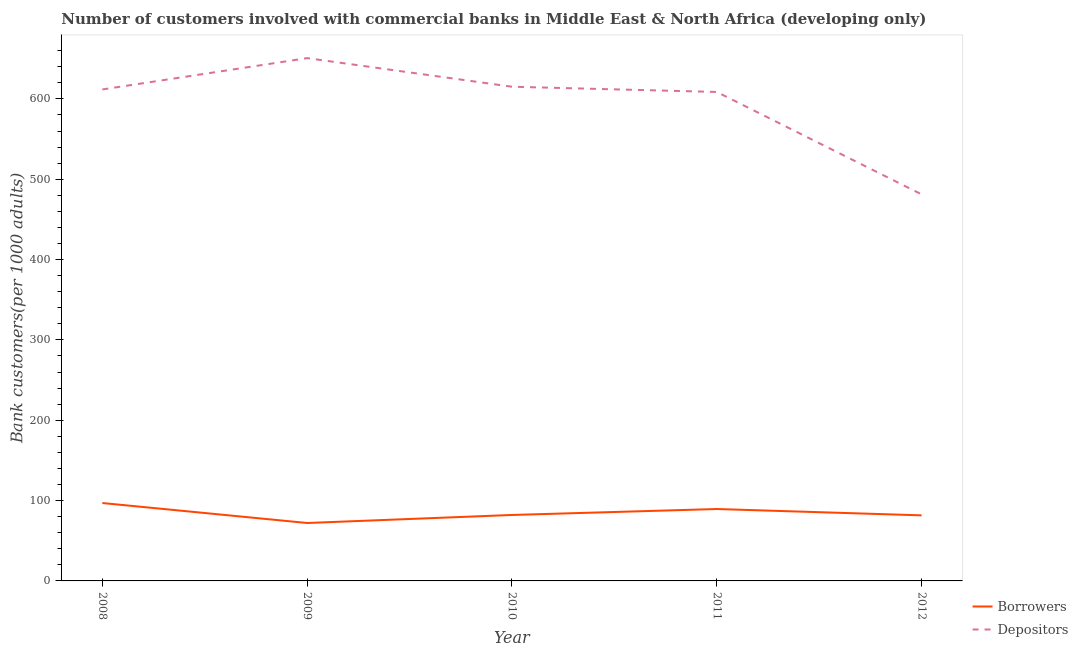How many different coloured lines are there?
Offer a very short reply. 2. Is the number of lines equal to the number of legend labels?
Your answer should be compact. Yes. What is the number of depositors in 2009?
Your answer should be very brief. 650.77. Across all years, what is the maximum number of borrowers?
Give a very brief answer. 96.96. Across all years, what is the minimum number of borrowers?
Offer a terse response. 72.11. What is the total number of depositors in the graph?
Your answer should be very brief. 2967.5. What is the difference between the number of borrowers in 2011 and that in 2012?
Your answer should be compact. 7.9. What is the difference between the number of depositors in 2009 and the number of borrowers in 2010?
Offer a very short reply. 568.67. What is the average number of borrowers per year?
Provide a succinct answer. 84.46. In the year 2010, what is the difference between the number of borrowers and number of depositors?
Provide a succinct answer. -533.06. What is the ratio of the number of depositors in 2009 to that in 2011?
Your answer should be very brief. 1.07. Is the difference between the number of borrowers in 2010 and 2012 greater than the difference between the number of depositors in 2010 and 2012?
Give a very brief answer. No. What is the difference between the highest and the second highest number of depositors?
Give a very brief answer. 35.61. What is the difference between the highest and the lowest number of borrowers?
Offer a very short reply. 24.86. Does the number of borrowers monotonically increase over the years?
Give a very brief answer. No. Is the number of depositors strictly greater than the number of borrowers over the years?
Provide a succinct answer. Yes. Is the number of depositors strictly less than the number of borrowers over the years?
Your answer should be compact. No. How many lines are there?
Keep it short and to the point. 2. How many years are there in the graph?
Offer a very short reply. 5. Does the graph contain any zero values?
Provide a short and direct response. No. Does the graph contain grids?
Make the answer very short. No. Where does the legend appear in the graph?
Your answer should be very brief. Bottom right. How many legend labels are there?
Your answer should be very brief. 2. How are the legend labels stacked?
Your answer should be compact. Vertical. What is the title of the graph?
Ensure brevity in your answer.  Number of customers involved with commercial banks in Middle East & North Africa (developing only). What is the label or title of the X-axis?
Ensure brevity in your answer.  Year. What is the label or title of the Y-axis?
Your response must be concise. Bank customers(per 1000 adults). What is the Bank customers(per 1000 adults) in Borrowers in 2008?
Your response must be concise. 96.96. What is the Bank customers(per 1000 adults) in Depositors in 2008?
Provide a short and direct response. 611.77. What is the Bank customers(per 1000 adults) in Borrowers in 2009?
Give a very brief answer. 72.11. What is the Bank customers(per 1000 adults) of Depositors in 2009?
Provide a succinct answer. 650.77. What is the Bank customers(per 1000 adults) in Borrowers in 2010?
Your answer should be very brief. 82.1. What is the Bank customers(per 1000 adults) in Depositors in 2010?
Provide a short and direct response. 615.16. What is the Bank customers(per 1000 adults) in Borrowers in 2011?
Your response must be concise. 89.5. What is the Bank customers(per 1000 adults) in Depositors in 2011?
Make the answer very short. 608.64. What is the Bank customers(per 1000 adults) of Borrowers in 2012?
Offer a terse response. 81.61. What is the Bank customers(per 1000 adults) in Depositors in 2012?
Provide a short and direct response. 481.17. Across all years, what is the maximum Bank customers(per 1000 adults) in Borrowers?
Offer a very short reply. 96.96. Across all years, what is the maximum Bank customers(per 1000 adults) of Depositors?
Provide a short and direct response. 650.77. Across all years, what is the minimum Bank customers(per 1000 adults) in Borrowers?
Provide a succinct answer. 72.11. Across all years, what is the minimum Bank customers(per 1000 adults) in Depositors?
Give a very brief answer. 481.17. What is the total Bank customers(per 1000 adults) of Borrowers in the graph?
Offer a very short reply. 422.28. What is the total Bank customers(per 1000 adults) of Depositors in the graph?
Your response must be concise. 2967.5. What is the difference between the Bank customers(per 1000 adults) of Borrowers in 2008 and that in 2009?
Your answer should be compact. 24.86. What is the difference between the Bank customers(per 1000 adults) of Depositors in 2008 and that in 2009?
Provide a succinct answer. -39. What is the difference between the Bank customers(per 1000 adults) of Borrowers in 2008 and that in 2010?
Ensure brevity in your answer.  14.86. What is the difference between the Bank customers(per 1000 adults) in Depositors in 2008 and that in 2010?
Your response must be concise. -3.39. What is the difference between the Bank customers(per 1000 adults) in Borrowers in 2008 and that in 2011?
Your answer should be very brief. 7.46. What is the difference between the Bank customers(per 1000 adults) in Depositors in 2008 and that in 2011?
Your answer should be compact. 3.13. What is the difference between the Bank customers(per 1000 adults) in Borrowers in 2008 and that in 2012?
Your response must be concise. 15.36. What is the difference between the Bank customers(per 1000 adults) of Depositors in 2008 and that in 2012?
Offer a terse response. 130.6. What is the difference between the Bank customers(per 1000 adults) of Borrowers in 2009 and that in 2010?
Your response must be concise. -10. What is the difference between the Bank customers(per 1000 adults) of Depositors in 2009 and that in 2010?
Your answer should be very brief. 35.61. What is the difference between the Bank customers(per 1000 adults) in Borrowers in 2009 and that in 2011?
Offer a very short reply. -17.4. What is the difference between the Bank customers(per 1000 adults) of Depositors in 2009 and that in 2011?
Your response must be concise. 42.13. What is the difference between the Bank customers(per 1000 adults) in Borrowers in 2009 and that in 2012?
Provide a succinct answer. -9.5. What is the difference between the Bank customers(per 1000 adults) in Depositors in 2009 and that in 2012?
Give a very brief answer. 169.6. What is the difference between the Bank customers(per 1000 adults) of Borrowers in 2010 and that in 2011?
Offer a very short reply. -7.4. What is the difference between the Bank customers(per 1000 adults) in Depositors in 2010 and that in 2011?
Provide a succinct answer. 6.52. What is the difference between the Bank customers(per 1000 adults) of Borrowers in 2010 and that in 2012?
Make the answer very short. 0.5. What is the difference between the Bank customers(per 1000 adults) in Depositors in 2010 and that in 2012?
Give a very brief answer. 133.99. What is the difference between the Bank customers(per 1000 adults) of Borrowers in 2011 and that in 2012?
Make the answer very short. 7.9. What is the difference between the Bank customers(per 1000 adults) in Depositors in 2011 and that in 2012?
Give a very brief answer. 127.47. What is the difference between the Bank customers(per 1000 adults) in Borrowers in 2008 and the Bank customers(per 1000 adults) in Depositors in 2009?
Your response must be concise. -553.8. What is the difference between the Bank customers(per 1000 adults) in Borrowers in 2008 and the Bank customers(per 1000 adults) in Depositors in 2010?
Provide a succinct answer. -518.19. What is the difference between the Bank customers(per 1000 adults) of Borrowers in 2008 and the Bank customers(per 1000 adults) of Depositors in 2011?
Offer a very short reply. -511.68. What is the difference between the Bank customers(per 1000 adults) in Borrowers in 2008 and the Bank customers(per 1000 adults) in Depositors in 2012?
Provide a short and direct response. -384.21. What is the difference between the Bank customers(per 1000 adults) in Borrowers in 2009 and the Bank customers(per 1000 adults) in Depositors in 2010?
Offer a very short reply. -543.05. What is the difference between the Bank customers(per 1000 adults) of Borrowers in 2009 and the Bank customers(per 1000 adults) of Depositors in 2011?
Your answer should be very brief. -536.53. What is the difference between the Bank customers(per 1000 adults) of Borrowers in 2009 and the Bank customers(per 1000 adults) of Depositors in 2012?
Provide a succinct answer. -409.06. What is the difference between the Bank customers(per 1000 adults) of Borrowers in 2010 and the Bank customers(per 1000 adults) of Depositors in 2011?
Provide a succinct answer. -526.54. What is the difference between the Bank customers(per 1000 adults) in Borrowers in 2010 and the Bank customers(per 1000 adults) in Depositors in 2012?
Ensure brevity in your answer.  -399.07. What is the difference between the Bank customers(per 1000 adults) of Borrowers in 2011 and the Bank customers(per 1000 adults) of Depositors in 2012?
Make the answer very short. -391.67. What is the average Bank customers(per 1000 adults) in Borrowers per year?
Your answer should be very brief. 84.46. What is the average Bank customers(per 1000 adults) of Depositors per year?
Ensure brevity in your answer.  593.5. In the year 2008, what is the difference between the Bank customers(per 1000 adults) of Borrowers and Bank customers(per 1000 adults) of Depositors?
Give a very brief answer. -514.8. In the year 2009, what is the difference between the Bank customers(per 1000 adults) in Borrowers and Bank customers(per 1000 adults) in Depositors?
Keep it short and to the point. -578.66. In the year 2010, what is the difference between the Bank customers(per 1000 adults) of Borrowers and Bank customers(per 1000 adults) of Depositors?
Keep it short and to the point. -533.06. In the year 2011, what is the difference between the Bank customers(per 1000 adults) of Borrowers and Bank customers(per 1000 adults) of Depositors?
Your answer should be very brief. -519.14. In the year 2012, what is the difference between the Bank customers(per 1000 adults) in Borrowers and Bank customers(per 1000 adults) in Depositors?
Your answer should be very brief. -399.56. What is the ratio of the Bank customers(per 1000 adults) in Borrowers in 2008 to that in 2009?
Offer a very short reply. 1.34. What is the ratio of the Bank customers(per 1000 adults) of Depositors in 2008 to that in 2009?
Ensure brevity in your answer.  0.94. What is the ratio of the Bank customers(per 1000 adults) of Borrowers in 2008 to that in 2010?
Provide a succinct answer. 1.18. What is the ratio of the Bank customers(per 1000 adults) of Borrowers in 2008 to that in 2011?
Offer a very short reply. 1.08. What is the ratio of the Bank customers(per 1000 adults) in Borrowers in 2008 to that in 2012?
Your answer should be compact. 1.19. What is the ratio of the Bank customers(per 1000 adults) in Depositors in 2008 to that in 2012?
Your response must be concise. 1.27. What is the ratio of the Bank customers(per 1000 adults) in Borrowers in 2009 to that in 2010?
Offer a terse response. 0.88. What is the ratio of the Bank customers(per 1000 adults) in Depositors in 2009 to that in 2010?
Your answer should be very brief. 1.06. What is the ratio of the Bank customers(per 1000 adults) in Borrowers in 2009 to that in 2011?
Provide a succinct answer. 0.81. What is the ratio of the Bank customers(per 1000 adults) in Depositors in 2009 to that in 2011?
Your response must be concise. 1.07. What is the ratio of the Bank customers(per 1000 adults) in Borrowers in 2009 to that in 2012?
Your answer should be compact. 0.88. What is the ratio of the Bank customers(per 1000 adults) of Depositors in 2009 to that in 2012?
Your answer should be very brief. 1.35. What is the ratio of the Bank customers(per 1000 adults) of Borrowers in 2010 to that in 2011?
Offer a very short reply. 0.92. What is the ratio of the Bank customers(per 1000 adults) of Depositors in 2010 to that in 2011?
Provide a succinct answer. 1.01. What is the ratio of the Bank customers(per 1000 adults) in Borrowers in 2010 to that in 2012?
Ensure brevity in your answer.  1.01. What is the ratio of the Bank customers(per 1000 adults) in Depositors in 2010 to that in 2012?
Give a very brief answer. 1.28. What is the ratio of the Bank customers(per 1000 adults) of Borrowers in 2011 to that in 2012?
Keep it short and to the point. 1.1. What is the ratio of the Bank customers(per 1000 adults) of Depositors in 2011 to that in 2012?
Offer a terse response. 1.26. What is the difference between the highest and the second highest Bank customers(per 1000 adults) in Borrowers?
Provide a succinct answer. 7.46. What is the difference between the highest and the second highest Bank customers(per 1000 adults) in Depositors?
Keep it short and to the point. 35.61. What is the difference between the highest and the lowest Bank customers(per 1000 adults) of Borrowers?
Offer a terse response. 24.86. What is the difference between the highest and the lowest Bank customers(per 1000 adults) in Depositors?
Give a very brief answer. 169.6. 